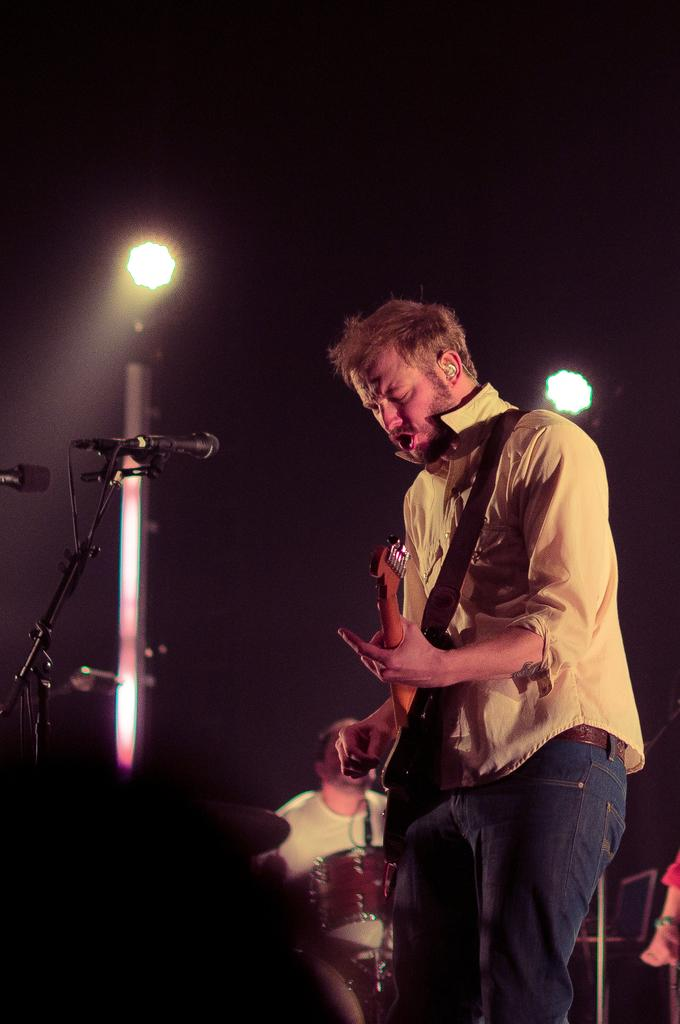What is the person in the image doing? The person is standing in front of a mic and holding a guitar. What can be seen behind the person? There are lights in the background of the image. Are there any other people in the image? Yes, there is a person sitting in the background of the image. What type of berry is being used to adjust the acoustics in the image? There is no berry present in the image, and berries are not used to adjust acoustics. 